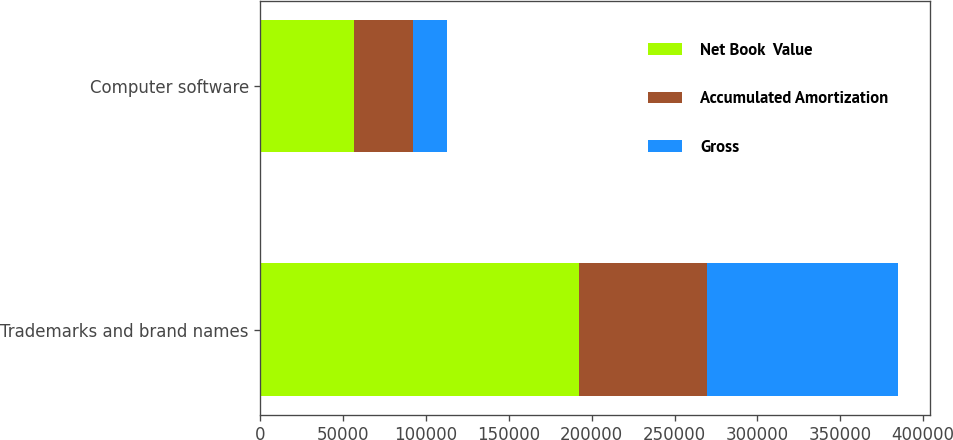<chart> <loc_0><loc_0><loc_500><loc_500><stacked_bar_chart><ecel><fcel>Trademarks and brand names<fcel>Computer software<nl><fcel>Net Book  Value<fcel>192440<fcel>56356<nl><fcel>Accumulated Amortization<fcel>77146<fcel>35436<nl><fcel>Gross<fcel>115294<fcel>20920<nl></chart> 